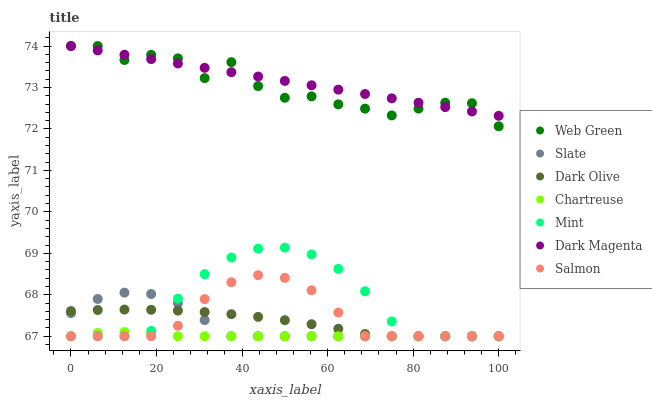Does Chartreuse have the minimum area under the curve?
Answer yes or no. Yes. Does Dark Magenta have the maximum area under the curve?
Answer yes or no. Yes. Does Slate have the minimum area under the curve?
Answer yes or no. No. Does Slate have the maximum area under the curve?
Answer yes or no. No. Is Dark Magenta the smoothest?
Answer yes or no. Yes. Is Web Green the roughest?
Answer yes or no. Yes. Is Slate the smoothest?
Answer yes or no. No. Is Slate the roughest?
Answer yes or no. No. Does Slate have the lowest value?
Answer yes or no. Yes. Does Web Green have the lowest value?
Answer yes or no. No. Does Web Green have the highest value?
Answer yes or no. Yes. Does Slate have the highest value?
Answer yes or no. No. Is Mint less than Dark Magenta?
Answer yes or no. Yes. Is Dark Magenta greater than Slate?
Answer yes or no. Yes. Does Mint intersect Salmon?
Answer yes or no. Yes. Is Mint less than Salmon?
Answer yes or no. No. Is Mint greater than Salmon?
Answer yes or no. No. Does Mint intersect Dark Magenta?
Answer yes or no. No. 